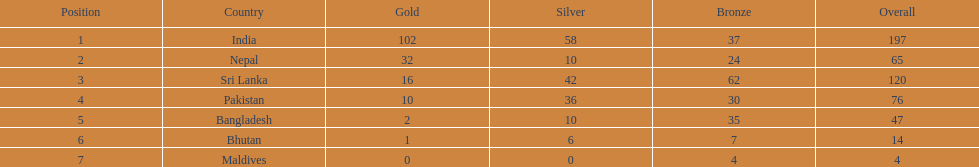What country has won no silver medals? Maldives. 